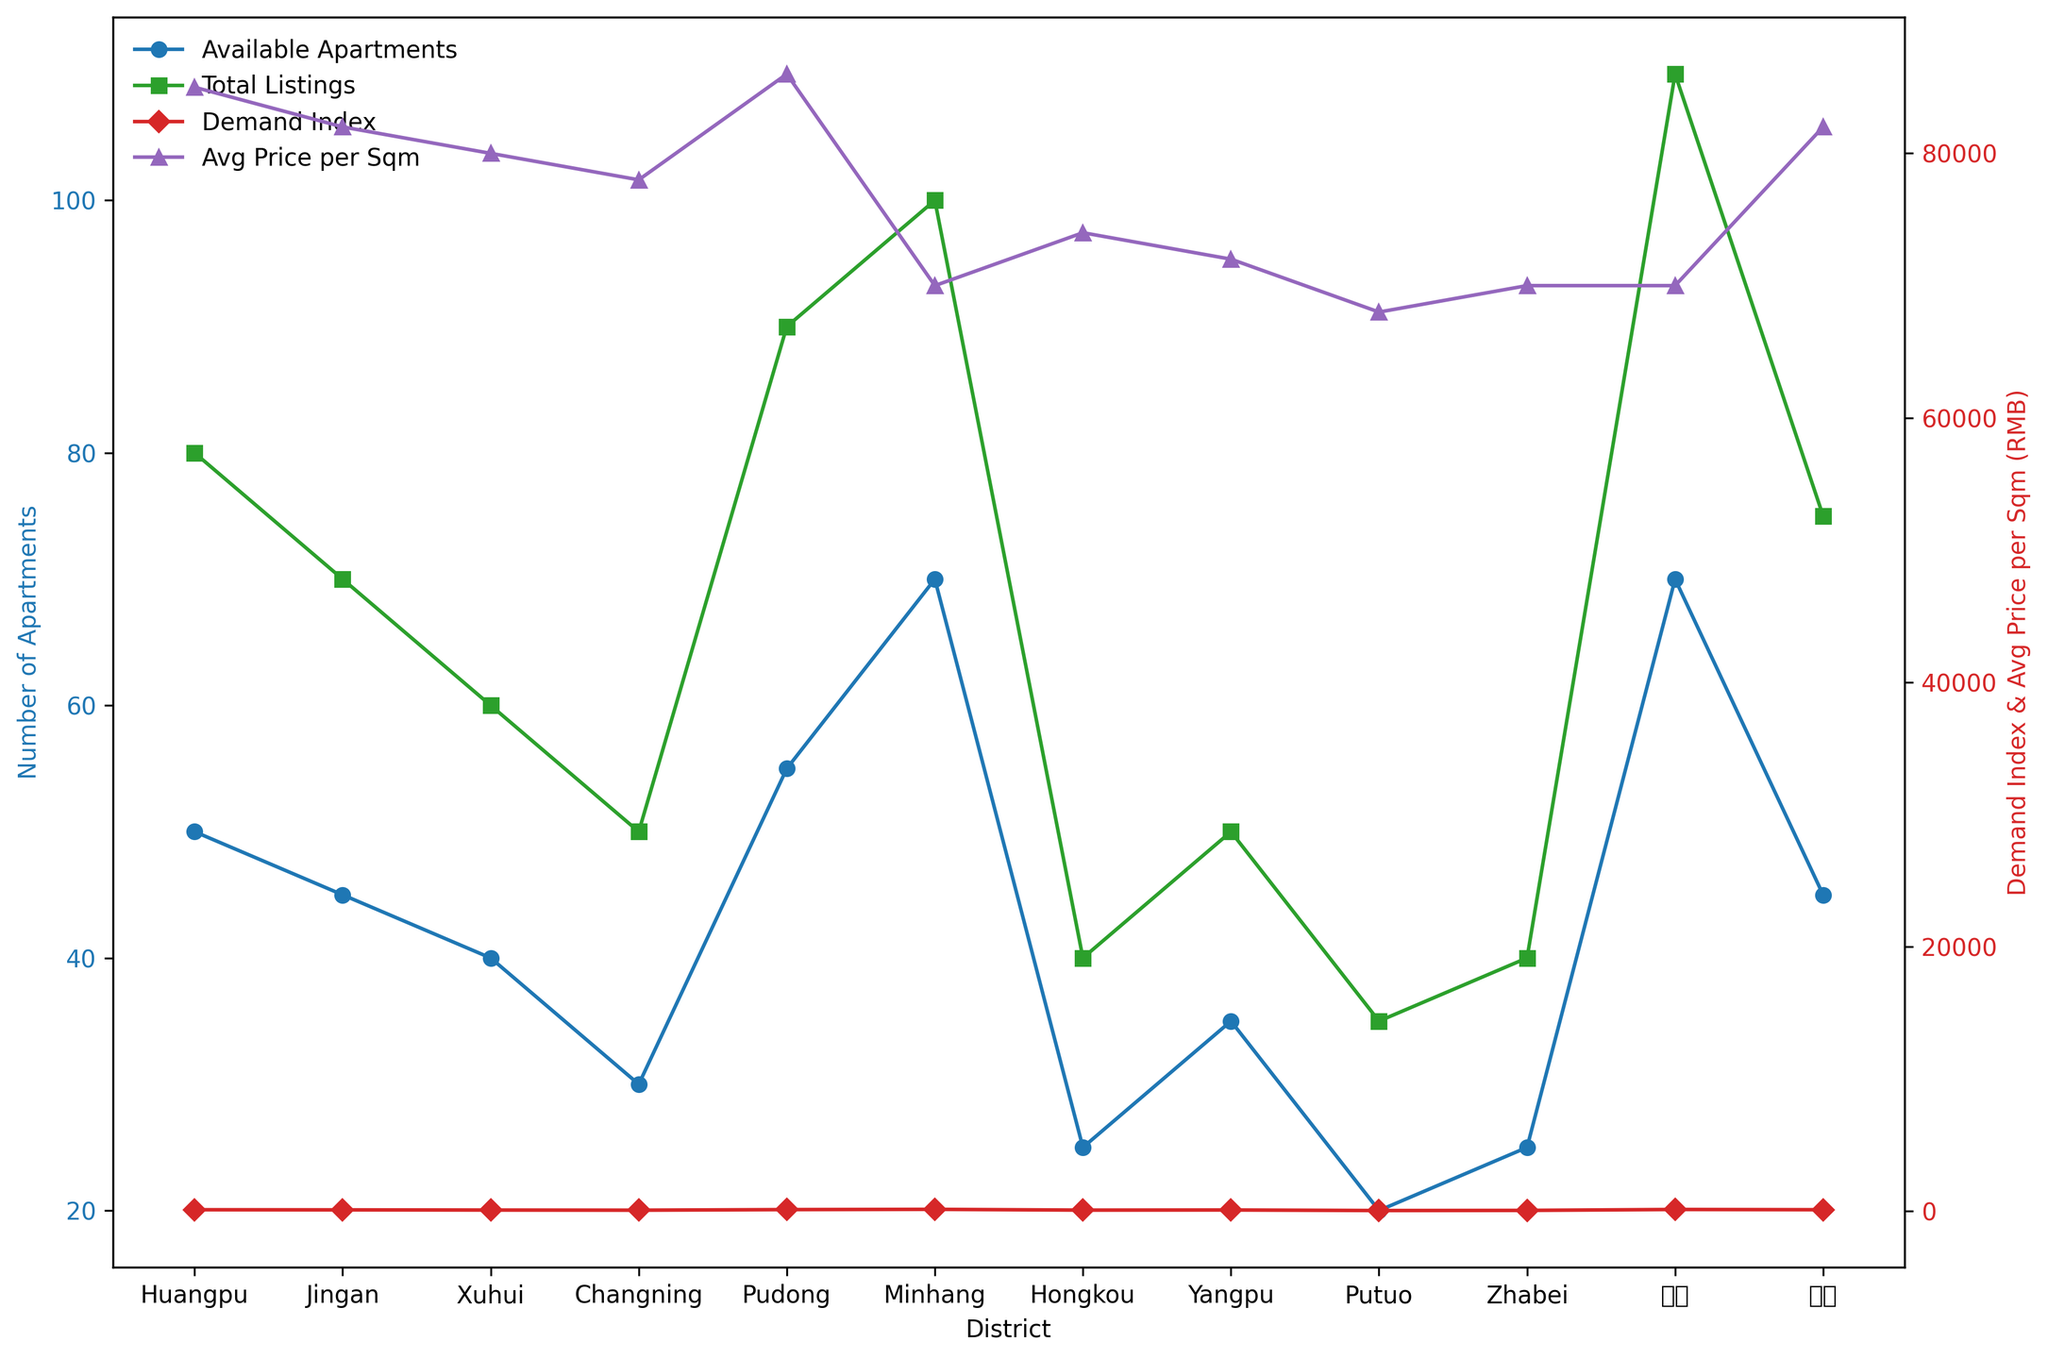What is the district with the highest demand index? To find the district with the highest demand index, look at the red line representing "Demand Index." Identify the district with the tallest red marker labeled "D." The highest marker is found in Minhang, which has a demand index of 150.
Answer: Minhang Which district has the lowest number of available apartments? To identify the district with the lowest number of available apartments, observe the blue line representing "Available Apartments." Find the district with the lowest blue marker labeled "o." The lowest marker is in Putuo, which has 20 available apartments.
Answer: Putuo How many more available apartments are there in Pudong compared to Putuo? First, locate Pudong and Putuo on the blue line representing "Available Apartments." Pudong has 55 available apartments, and Putuo has 20. Subtract Putuo's apartments from Pudong's: 55 - 20 = 35.
Answer: 35 more apartments Which district has the highest average price per sqm and what is its demand index? To find the district with the highest average price per sqm, look at the purple line labeled "Avg Price per Sqm." Identify the highest purple marker, which corresponds to Pudong at RMB 86,000 per sqm. The demand index for Pudong is represented by the red line and marker labeled "D" directly above Pudong, showing 130.
Answer: Pudong, 130 Compare the number of total listings between Jingan and Xuhui; which one has more? How many more? Find Jingan and Xuhui on the green line representing "Total Listings." Jingan has 70 total listings, and Xuhui has 60. Jingan has 70 - 60 = 10 more listings than Xuhui.
Answer: Jingan, 10 more 